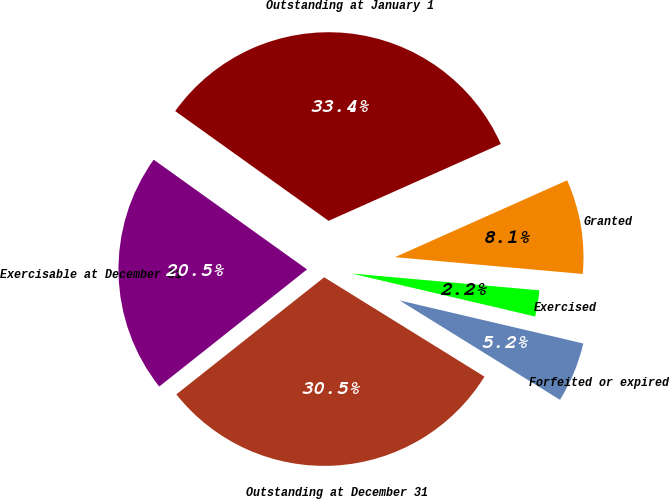Convert chart to OTSL. <chart><loc_0><loc_0><loc_500><loc_500><pie_chart><fcel>Outstanding at January 1<fcel>Granted<fcel>Exercised<fcel>Forfeited or expired<fcel>Outstanding at December 31<fcel>Exercisable at December 31<nl><fcel>33.44%<fcel>8.1%<fcel>2.24%<fcel>5.17%<fcel>30.51%<fcel>20.55%<nl></chart> 